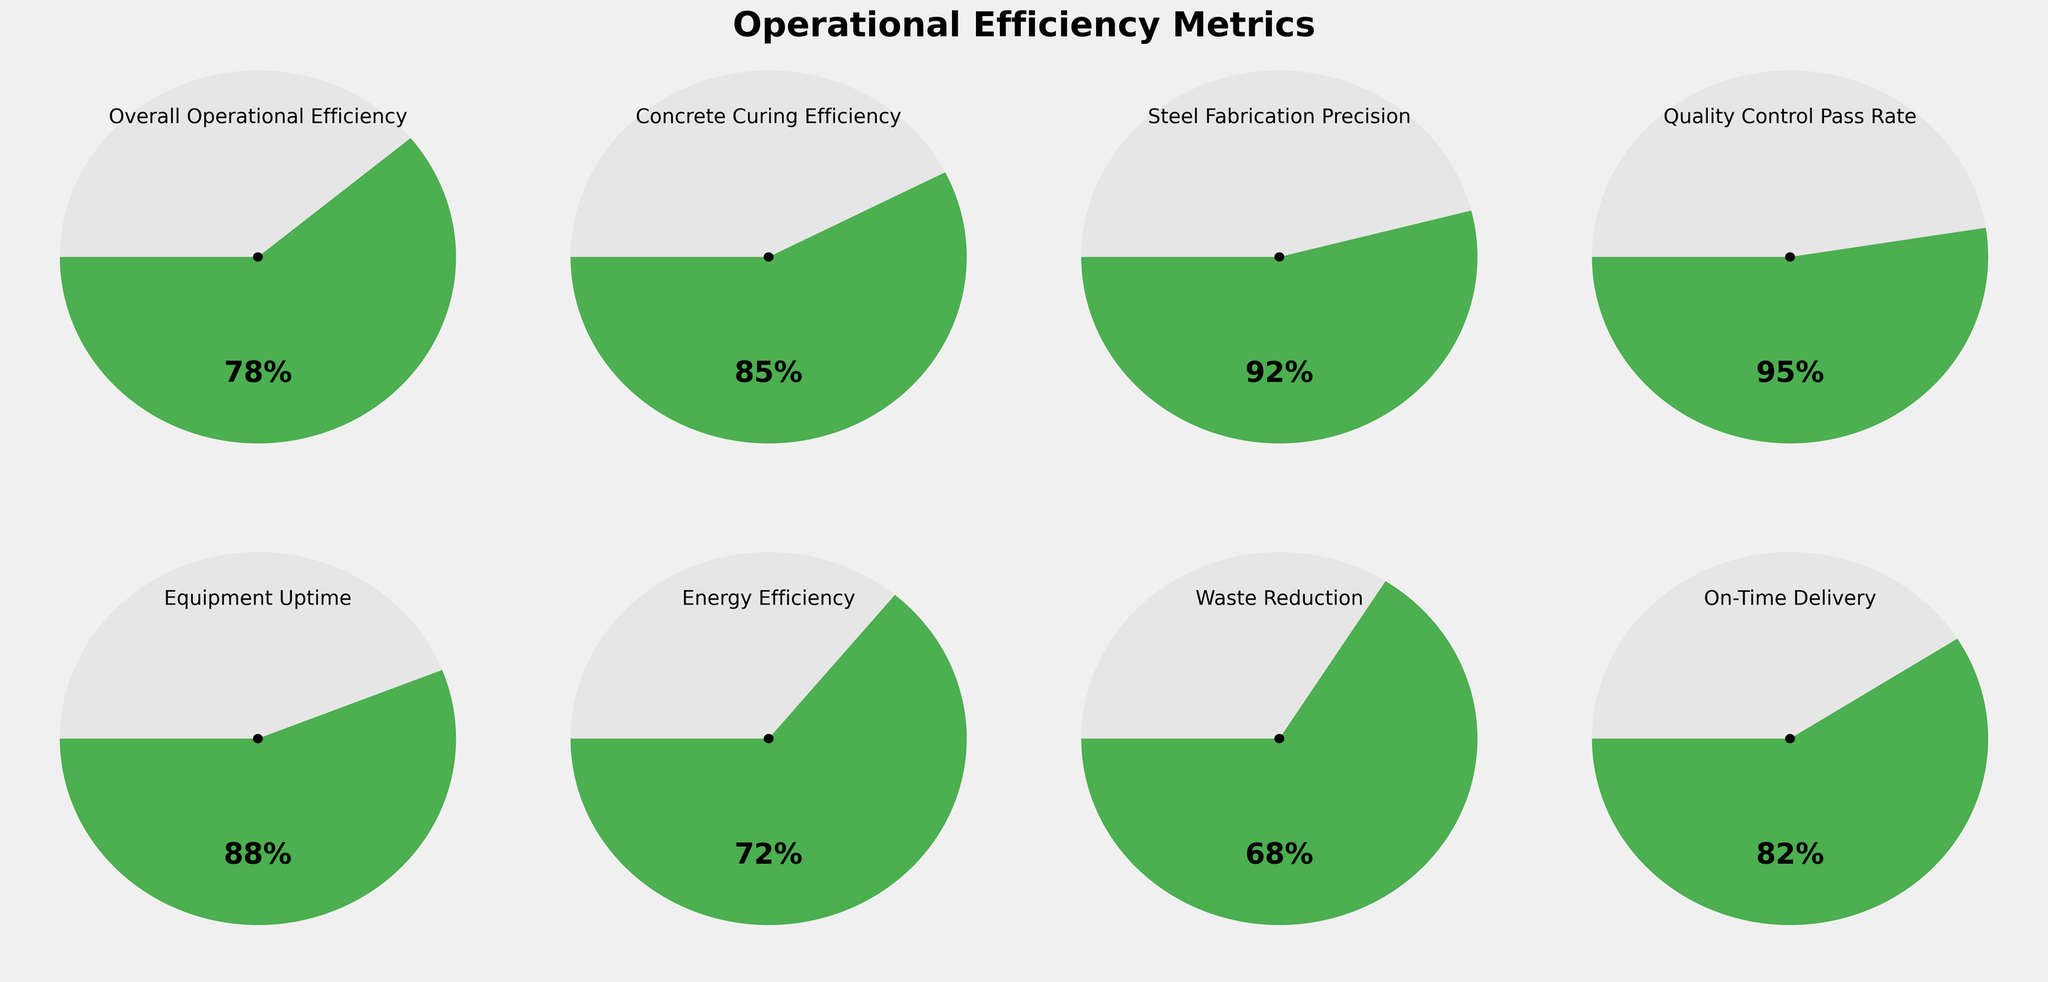Which metric has the highest efficiency value? By looking at the gauges, the metric with the highest value is 'Quality Control Pass Rate' at 95%.
Answer: Quality Control Pass Rate What is the title of the figure? The title is displayed at the top of the figure and reads "Operational Efficiency Metrics".
Answer: Operational Efficiency Metrics How does the 'Energy Efficiency' value compare to the 'Overall Operational Efficiency' value? The 'Energy Efficiency' value is 72%, which is lower than the 'Overall Operational Efficiency' value of 78%.
Answer: Energy Efficiency is lower What is the difference between 'Concrete Curing Efficiency' and 'Equipment Uptime'? 'Concrete Curing Efficiency' is 85% and 'Equipment Uptime' is 88%. The difference is 88 - 85 = 3%.
Answer: 3% Which metric shows the lowest efficiency value? The gauge with the lowest value displays 'Waste Reduction' at 68%.
Answer: Waste Reduction Arrange the metrics in descending order of their efficiency values. From the gauges, the order is: 'Quality Control Pass Rate' (95%), 'Steel Fabrication Precision'(92%), 'Equipment Uptime' (88%), 'Concrete Curing Efficiency' (85%), 'On-Time Delivery' (82%), 'Overall Operational Efficiency' (78%), 'Energy Efficiency' (72%), 'Waste Reduction' (68%).
Answer: Quality Control Pass Rate, Steel Fabrication Precision, Equipment Uptime, Concrete Curing Efficiency, On-Time Delivery, Overall Operational Efficiency, Energy Efficiency, Waste Reduction What is the average value of 'Concrete Curing Efficiency' and 'Steel Fabrication Precision'? The values are 85% and 92%. The average is (85 + 92) / 2 = 88.5%.
Answer: 88.5% Which metrics have values above 80%? By observing the gauges, the metrics with values above 80% are: 'Overall Operational Efficiency' (78%), 'Concrete Curing Efficiency' (85%), 'Steel Fabrication Precision' (92%), 'Quality Control Pass Rate' (95%), 'Equipment Uptime' (88%), 'On-Time Delivery' (82%).
Answer: Concrete Curing Efficiency, Steel Fabrication Precision, Quality Control Pass Rate, Equipment Uptime, On-Time Delivery Are there any metrics with values between 70% and 80%? The gauges show that 'Overall Operational Efficiency' (78%) and 'Energy Efficiency' (72%) fall within this range.
Answer: Overall Operational Efficiency, Energy Efficiency 